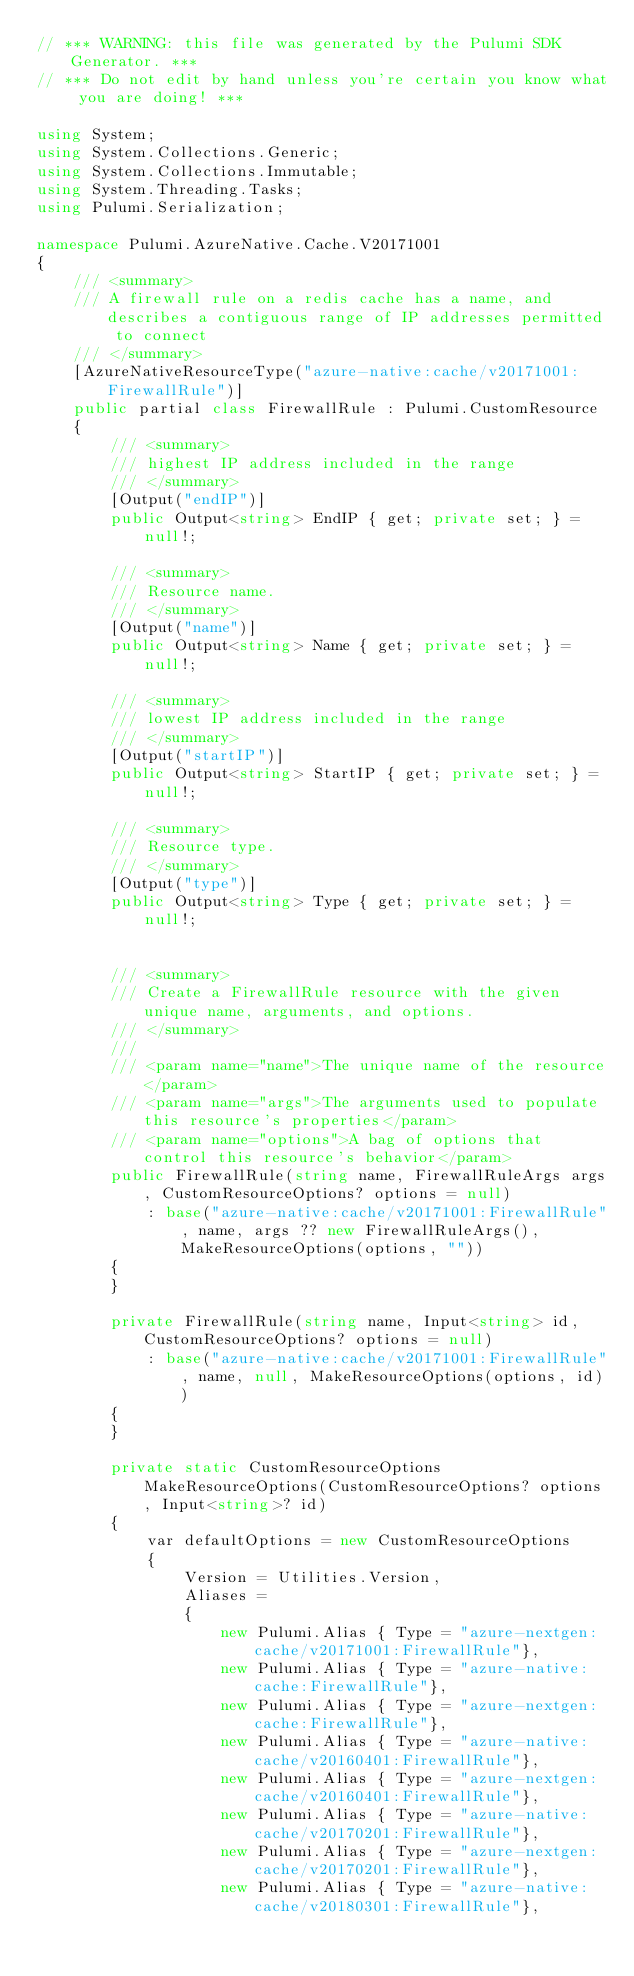Convert code to text. <code><loc_0><loc_0><loc_500><loc_500><_C#_>// *** WARNING: this file was generated by the Pulumi SDK Generator. ***
// *** Do not edit by hand unless you're certain you know what you are doing! ***

using System;
using System.Collections.Generic;
using System.Collections.Immutable;
using System.Threading.Tasks;
using Pulumi.Serialization;

namespace Pulumi.AzureNative.Cache.V20171001
{
    /// <summary>
    /// A firewall rule on a redis cache has a name, and describes a contiguous range of IP addresses permitted to connect
    /// </summary>
    [AzureNativeResourceType("azure-native:cache/v20171001:FirewallRule")]
    public partial class FirewallRule : Pulumi.CustomResource
    {
        /// <summary>
        /// highest IP address included in the range
        /// </summary>
        [Output("endIP")]
        public Output<string> EndIP { get; private set; } = null!;

        /// <summary>
        /// Resource name.
        /// </summary>
        [Output("name")]
        public Output<string> Name { get; private set; } = null!;

        /// <summary>
        /// lowest IP address included in the range
        /// </summary>
        [Output("startIP")]
        public Output<string> StartIP { get; private set; } = null!;

        /// <summary>
        /// Resource type.
        /// </summary>
        [Output("type")]
        public Output<string> Type { get; private set; } = null!;


        /// <summary>
        /// Create a FirewallRule resource with the given unique name, arguments, and options.
        /// </summary>
        ///
        /// <param name="name">The unique name of the resource</param>
        /// <param name="args">The arguments used to populate this resource's properties</param>
        /// <param name="options">A bag of options that control this resource's behavior</param>
        public FirewallRule(string name, FirewallRuleArgs args, CustomResourceOptions? options = null)
            : base("azure-native:cache/v20171001:FirewallRule", name, args ?? new FirewallRuleArgs(), MakeResourceOptions(options, ""))
        {
        }

        private FirewallRule(string name, Input<string> id, CustomResourceOptions? options = null)
            : base("azure-native:cache/v20171001:FirewallRule", name, null, MakeResourceOptions(options, id))
        {
        }

        private static CustomResourceOptions MakeResourceOptions(CustomResourceOptions? options, Input<string>? id)
        {
            var defaultOptions = new CustomResourceOptions
            {
                Version = Utilities.Version,
                Aliases =
                {
                    new Pulumi.Alias { Type = "azure-nextgen:cache/v20171001:FirewallRule"},
                    new Pulumi.Alias { Type = "azure-native:cache:FirewallRule"},
                    new Pulumi.Alias { Type = "azure-nextgen:cache:FirewallRule"},
                    new Pulumi.Alias { Type = "azure-native:cache/v20160401:FirewallRule"},
                    new Pulumi.Alias { Type = "azure-nextgen:cache/v20160401:FirewallRule"},
                    new Pulumi.Alias { Type = "azure-native:cache/v20170201:FirewallRule"},
                    new Pulumi.Alias { Type = "azure-nextgen:cache/v20170201:FirewallRule"},
                    new Pulumi.Alias { Type = "azure-native:cache/v20180301:FirewallRule"},</code> 